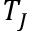Convert formula to latex. <formula><loc_0><loc_0><loc_500><loc_500>T _ { J }</formula> 